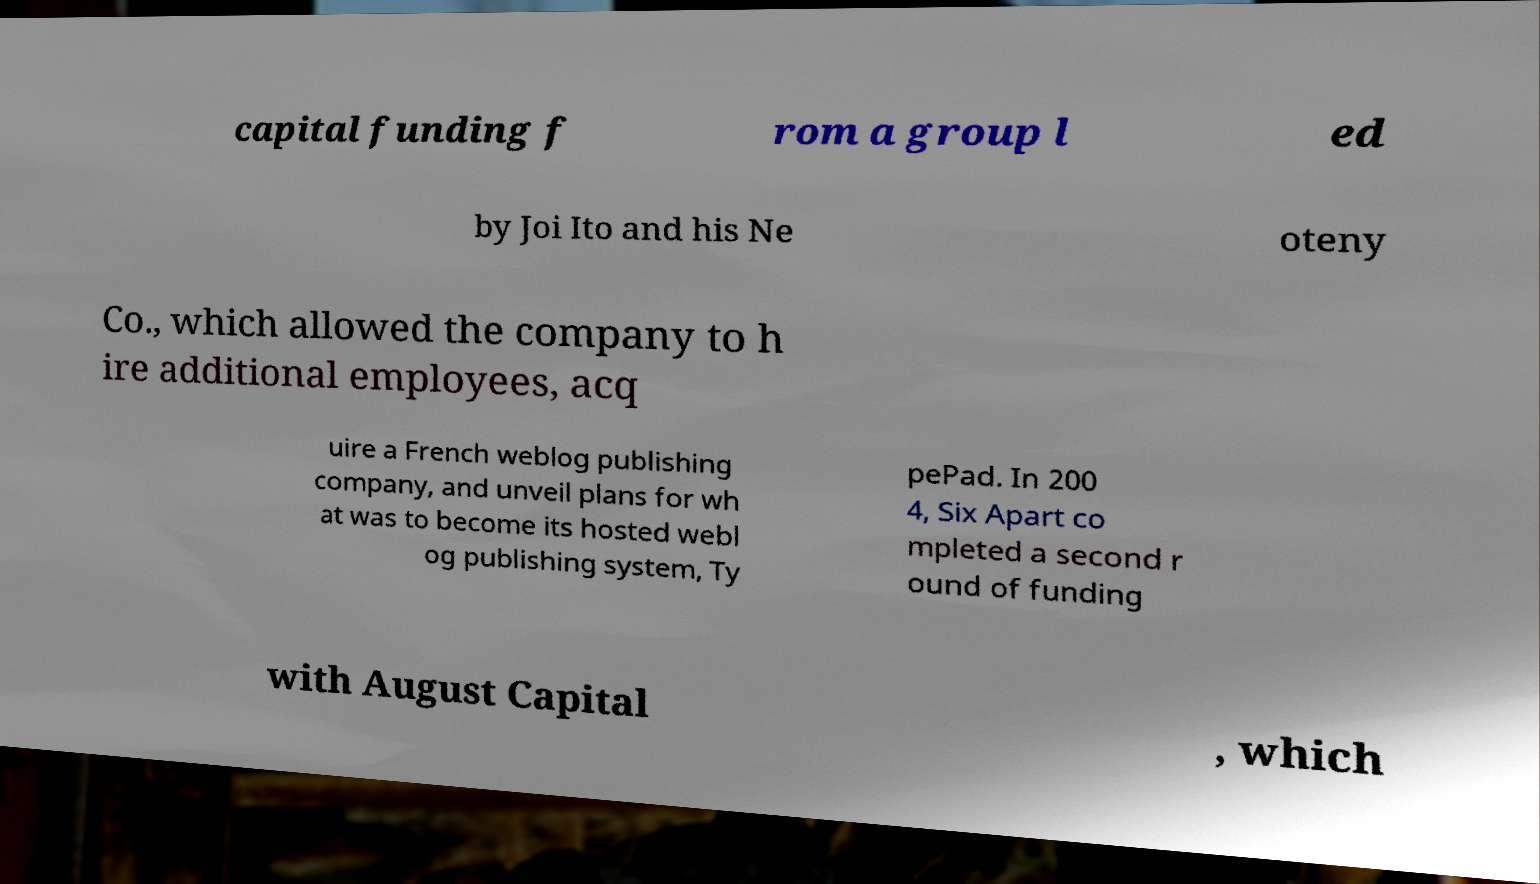Can you read and provide the text displayed in the image?This photo seems to have some interesting text. Can you extract and type it out for me? capital funding f rom a group l ed by Joi Ito and his Ne oteny Co., which allowed the company to h ire additional employees, acq uire a French weblog publishing company, and unveil plans for wh at was to become its hosted webl og publishing system, Ty pePad. In 200 4, Six Apart co mpleted a second r ound of funding with August Capital , which 